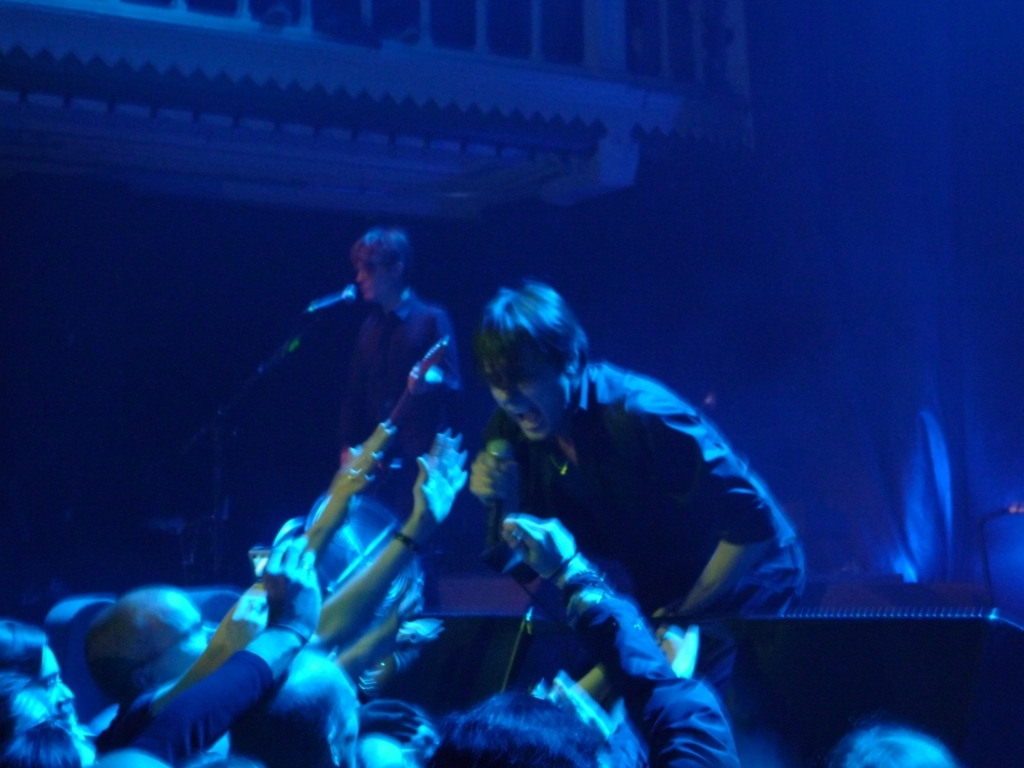What kind of emotions does this image evoke? This image evokes feelings of excitement and intensity, a sense of thrill that comes from live music performances. The interaction between the performer and the crowd suggests a shared passion and enthusiasm for the moment. Could you comment on the audience's engagement in the performance? Certainly, the audience appears highly engaged with the performance. They are reaching towards the artist, indicating active participation. Such involvement suggests that they are captivated by the music and the presence of the performer. 